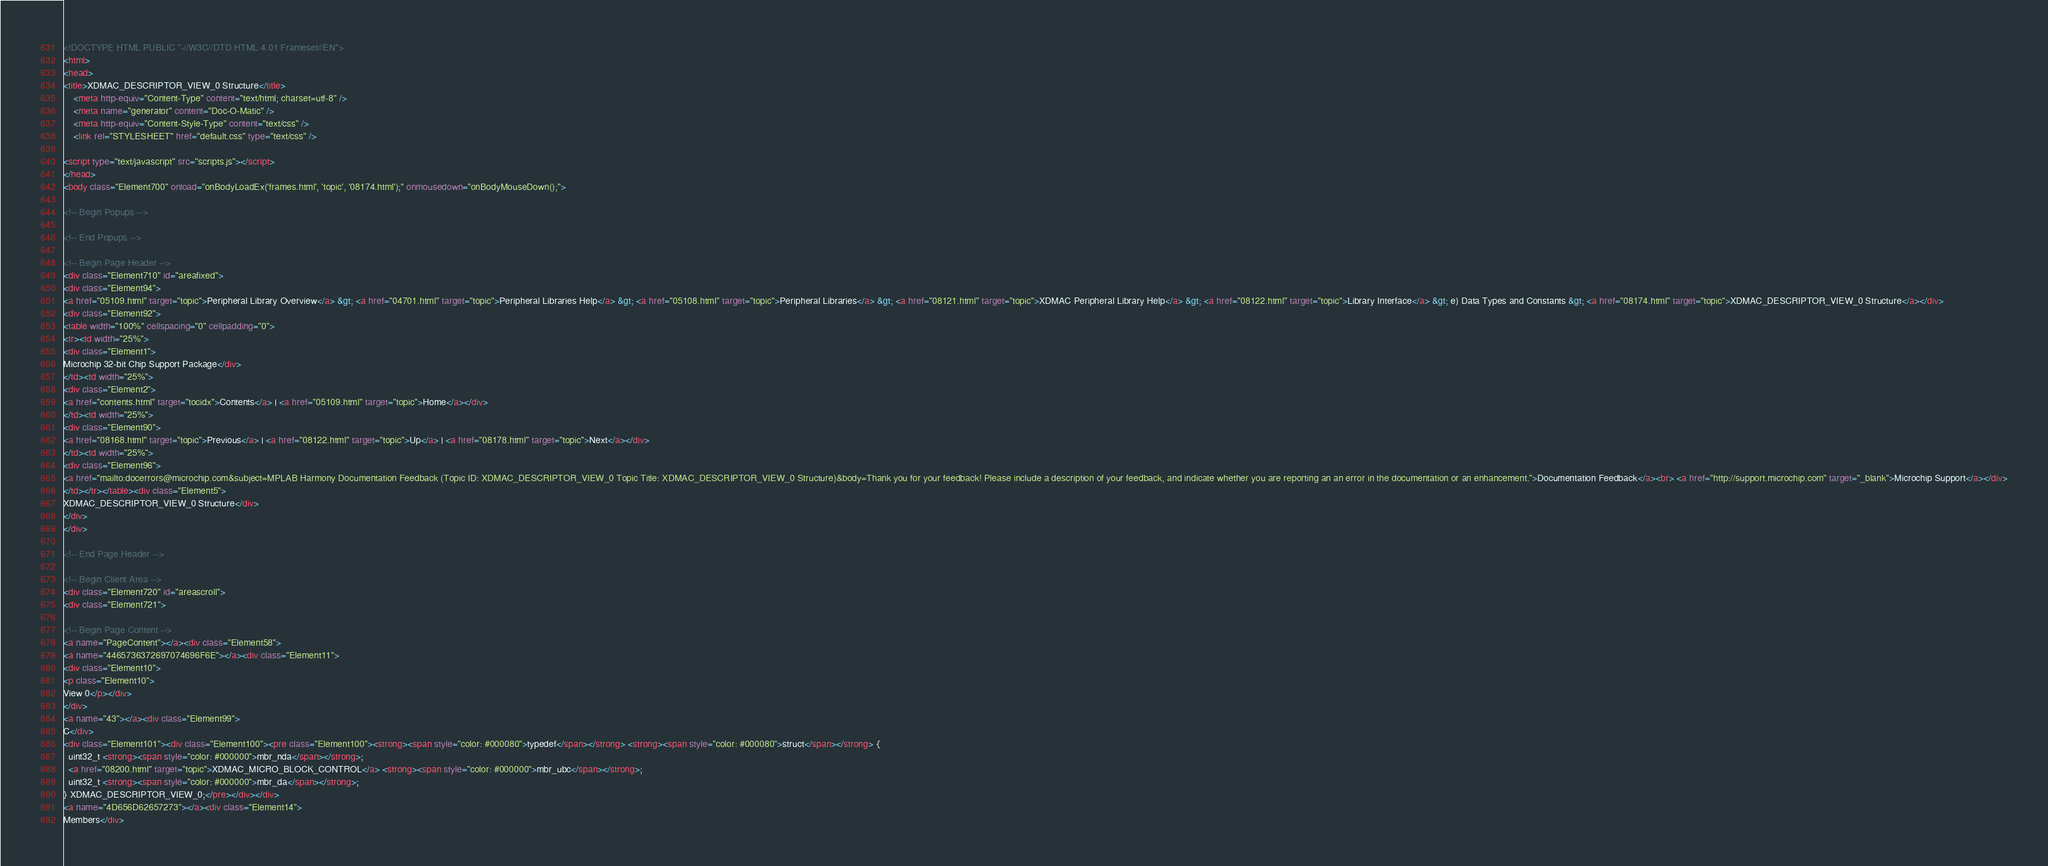Convert code to text. <code><loc_0><loc_0><loc_500><loc_500><_HTML_><!DOCTYPE HTML PUBLIC "-//W3C//DTD HTML 4.01 Frameset//EN">
<html>
<head>
<title>XDMAC_DESCRIPTOR_VIEW_0 Structure</title>
    <meta http-equiv="Content-Type" content="text/html; charset=utf-8" />
    <meta name="generator" content="Doc-O-Matic" />
    <meta http-equiv="Content-Style-Type" content="text/css" />
    <link rel="STYLESHEET" href="default.css" type="text/css" />

<script type="text/javascript" src="scripts.js"></script>
</head>
<body class="Element700" onload="onBodyLoadEx('frames.html', 'topic', '08174.html');" onmousedown="onBodyMouseDown();">

<!-- Begin Popups -->

<!-- End Popups -->

<!-- Begin Page Header -->
<div class="Element710" id="areafixed">
<div class="Element94">
<a href="05109.html" target="topic">Peripheral Library Overview</a> &gt; <a href="04701.html" target="topic">Peripheral Libraries Help</a> &gt; <a href="05108.html" target="topic">Peripheral Libraries</a> &gt; <a href="08121.html" target="topic">XDMAC Peripheral Library Help</a> &gt; <a href="08122.html" target="topic">Library Interface</a> &gt; e) Data Types and Constants &gt; <a href="08174.html" target="topic">XDMAC_DESCRIPTOR_VIEW_0 Structure</a></div>
<div class="Element92">
<table width="100%" cellspacing="0" cellpadding="0">
<tr><td width="25%">
<div class="Element1">
Microchip 32-bit Chip Support Package</div>
</td><td width="25%">
<div class="Element2">
<a href="contents.html" target="tocidx">Contents</a> | <a href="05109.html" target="topic">Home</a></div>
</td><td width="25%">
<div class="Element90">
<a href="08168.html" target="topic">Previous</a> | <a href="08122.html" target="topic">Up</a> | <a href="08178.html" target="topic">Next</a></div>
</td><td width="25%">
<div class="Element96">
<a href="mailto:docerrors@microchip.com&subject=MPLAB Harmony Documentation Feedback (Topic ID: XDMAC_DESCRIPTOR_VIEW_0 Topic Title: XDMAC_DESCRIPTOR_VIEW_0 Structure)&body=Thank you for your feedback! Please include a description of your feedback, and indicate whether you are reporting an an error in the documentation or an enhancement.">Documentation Feedback</a><br> <a href="http://support.microchip.com" target="_blank">Microchip Support</a></div>
</td></tr></table><div class="Element5">
XDMAC_DESCRIPTOR_VIEW_0 Structure</div>
</div>
</div>

<!-- End Page Header -->

<!-- Begin Client Area -->
<div class="Element720" id="areascroll">
<div class="Element721">

<!-- Begin Page Content -->
<a name="PageContent"></a><div class="Element58">
<a name="4465736372697074696F6E"></a><div class="Element11">
<div class="Element10">
<p class="Element10">
View 0</p></div>
</div>
<a name="43"></a><div class="Element99">
C</div>
<div class="Element101"><div class="Element100"><pre class="Element100"><strong><span style="color: #000080">typedef</span></strong> <strong><span style="color: #000080">struct</span></strong> {
  uint32_t <strong><span style="color: #000000">mbr_nda</span></strong>;
  <a href="08200.html" target="topic">XDMAC_MICRO_BLOCK_CONTROL</a> <strong><span style="color: #000000">mbr_ubc</span></strong>;
  uint32_t <strong><span style="color: #000000">mbr_da</span></strong>;
} XDMAC_DESCRIPTOR_VIEW_0;</pre></div></div>
<a name="4D656D62657273"></a><div class="Element14">
Members</div></code> 